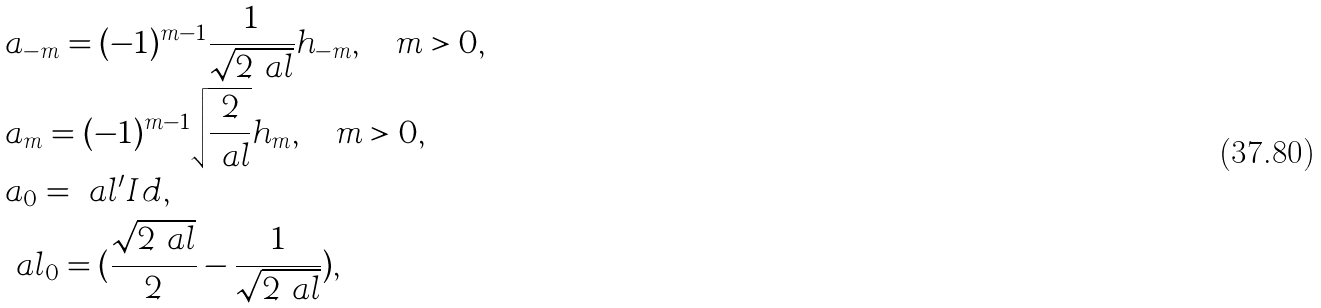<formula> <loc_0><loc_0><loc_500><loc_500>& a _ { - m } = ( - 1 ) ^ { m - 1 } \frac { 1 } { \sqrt { 2 \ a l } } h _ { - m } , \quad m > 0 , \\ & a _ { m } = ( - 1 ) ^ { m - 1 } \sqrt { \frac { 2 } { \ a l } } h _ { m } , \quad m > 0 , \\ & a _ { 0 } = \ a l ^ { \prime } I d , \\ & \ a l _ { 0 } = ( \frac { \sqrt { 2 \ a l } } { 2 } - \frac { 1 } { \sqrt { 2 \ a l } } ) ,</formula> 